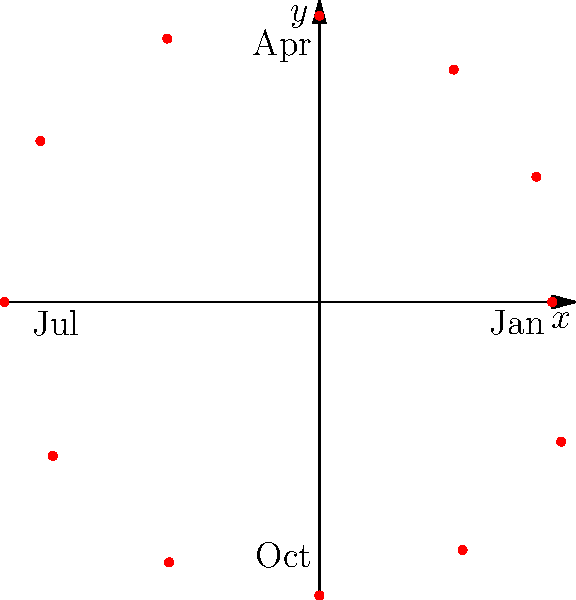In a polar coordinate plot representing mediation success rates over a year, with each month as a 30-degree increment and the radial distance indicating the success percentage, what is the approximate success rate for the month of April (90 degrees)? To solve this problem, we need to follow these steps:

1. Understand the polar coordinate system:
   - The angle represents the month (360 degrees / 12 months = 30 degrees per month)
   - The radial distance represents the success rate percentage

2. Identify April's position:
   - April is the 4th month
   - 4 months * 30 degrees = 90 degrees

3. Locate the point at 90 degrees on the plot:
   - This point is on the positive y-axis

4. Estimate the radial distance of this point:
   - The concentric circles are not labeled, but we can estimate based on the plot
   - The outermost circle appears to represent 100%
   - The point at 90 degrees seems to be about 80% of the way to the outermost circle

5. Conclude the success rate:
   - The estimated success rate for April (90 degrees) is approximately 80%

This analysis allows us to interpret mediation success rates throughout the year, which is crucial for curriculum development in alternative dispute resolution.
Answer: 80% 